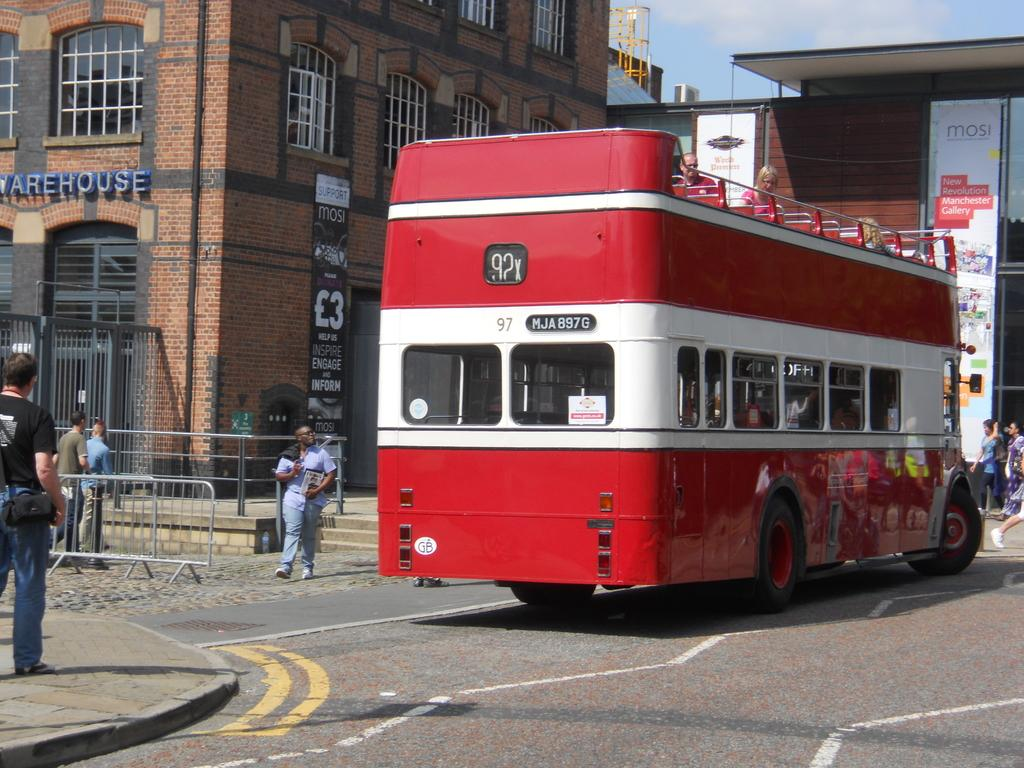<image>
Give a short and clear explanation of the subsequent image. A double-decker bus showing route 92X has the code MJA 897G on it. 